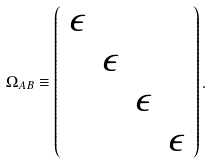<formula> <loc_0><loc_0><loc_500><loc_500>\Omega _ { A B } \equiv \left ( \begin{array} { c c c c } \epsilon & & & \\ & \epsilon & & \\ & & \epsilon & \\ & & & \epsilon \end{array} \right ) .</formula> 